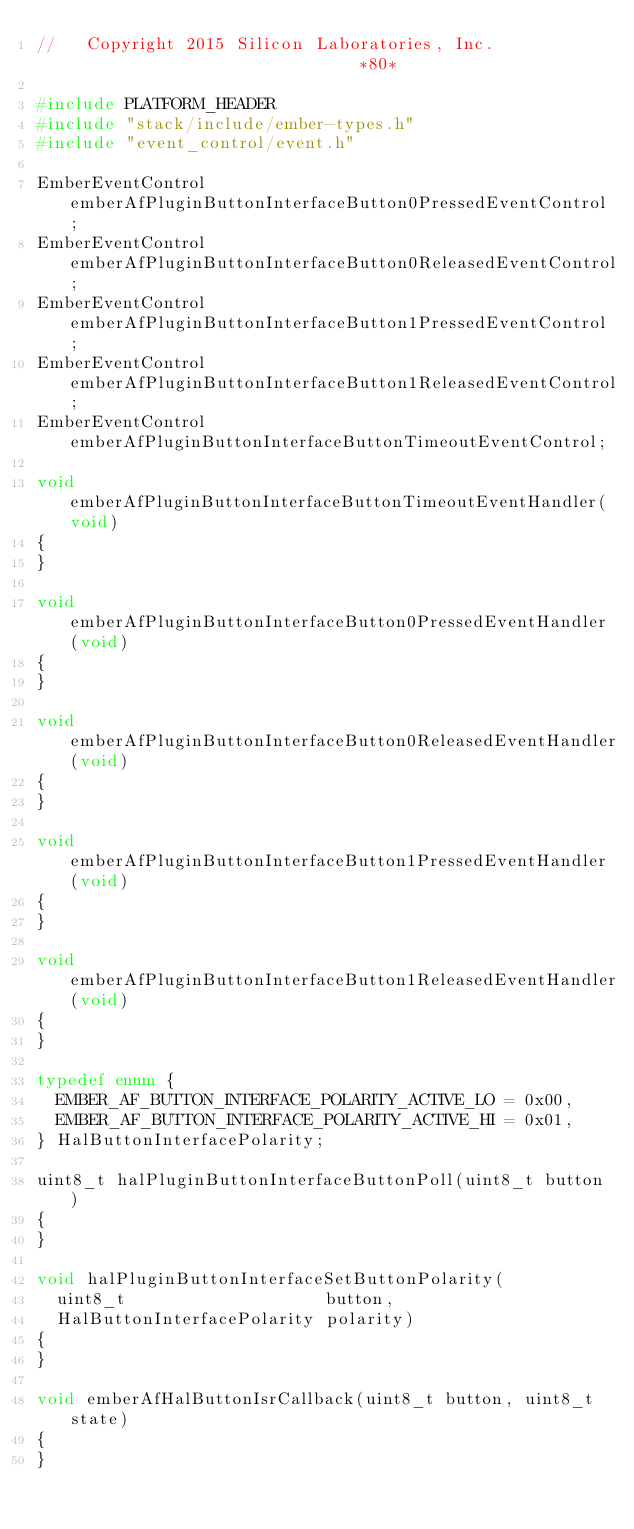<code> <loc_0><loc_0><loc_500><loc_500><_C_>//   Copyright 2015 Silicon Laboratories, Inc.                              *80*

#include PLATFORM_HEADER
#include "stack/include/ember-types.h"
#include "event_control/event.h"

EmberEventControl emberAfPluginButtonInterfaceButton0PressedEventControl;
EmberEventControl emberAfPluginButtonInterfaceButton0ReleasedEventControl;
EmberEventControl emberAfPluginButtonInterfaceButton1PressedEventControl;
EmberEventControl emberAfPluginButtonInterfaceButton1ReleasedEventControl;
EmberEventControl emberAfPluginButtonInterfaceButtonTimeoutEventControl;

void emberAfPluginButtonInterfaceButtonTimeoutEventHandler(void)
{
}

void emberAfPluginButtonInterfaceButton0PressedEventHandler(void)
{
}

void emberAfPluginButtonInterfaceButton0ReleasedEventHandler(void)
{
}

void emberAfPluginButtonInterfaceButton1PressedEventHandler(void)
{
}

void emberAfPluginButtonInterfaceButton1ReleasedEventHandler(void)
{
}

typedef enum {
  EMBER_AF_BUTTON_INTERFACE_POLARITY_ACTIVE_LO = 0x00,
  EMBER_AF_BUTTON_INTERFACE_POLARITY_ACTIVE_HI = 0x01,
} HalButtonInterfacePolarity;

uint8_t halPluginButtonInterfaceButtonPoll(uint8_t button)
{
}

void halPluginButtonInterfaceSetButtonPolarity(
  uint8_t                    button,
  HalButtonInterfacePolarity polarity)
{
}

void emberAfHalButtonIsrCallback(uint8_t button, uint8_t state)
{
}
</code> 